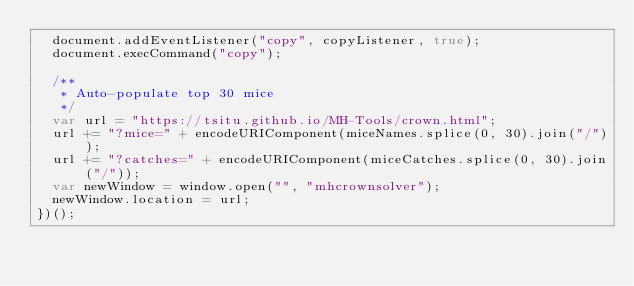Convert code to text. <code><loc_0><loc_0><loc_500><loc_500><_JavaScript_>  document.addEventListener("copy", copyListener, true);
  document.execCommand("copy");

  /**
   * Auto-populate top 30 mice
   */
  var url = "https://tsitu.github.io/MH-Tools/crown.html";
  url += "?mice=" + encodeURIComponent(miceNames.splice(0, 30).join("/"));
  url += "?catches=" + encodeURIComponent(miceCatches.splice(0, 30).join("/"));
  var newWindow = window.open("", "mhcrownsolver");
  newWindow.location = url;
})();
</code> 